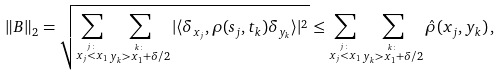<formula> <loc_0><loc_0><loc_500><loc_500>\| B \| _ { 2 } = \sqrt { \sum _ { \stackrel { j \colon } { x _ { j } < x _ { 1 } } } \sum _ { \stackrel { k \colon } { y _ { k } > x _ { 1 } + \delta / 2 } } | \langle \delta _ { x _ { j } } , \rho ( s _ { j } , t _ { k } ) \delta _ { y _ { k } } \rangle | ^ { 2 } } \leq \sum _ { \stackrel { j \colon } { x _ { j } < x _ { 1 } } } \sum _ { \stackrel { k \colon } { y _ { k } > x _ { 1 } + \delta / 2 } } \hat { \rho } ( x _ { j } , y _ { k } ) \, ,</formula> 